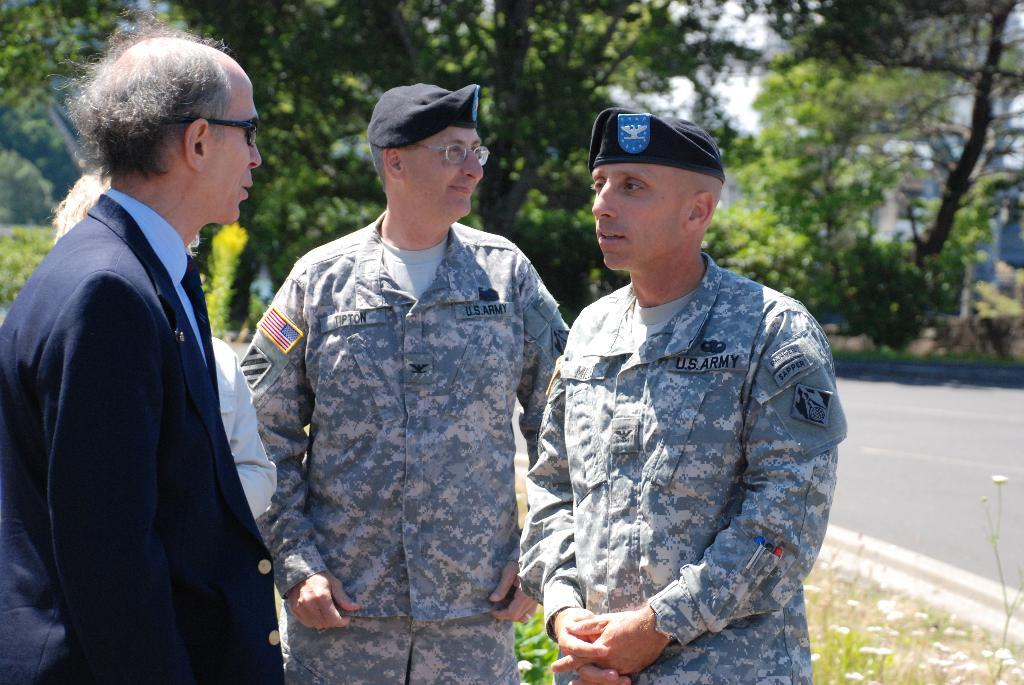Who is the main subject in the image? There is an old man in the image. What is the old man doing in the image? The old man is talking to an army official. Can you describe the other person in the image? There is another person in the background of the image, and they are looking somewhere. How many snails can be seen crawling on the army official's uniform in the image? There are no snails visible in the image. In which direction is the person in the background looking? The direction in which the person in the background is looking cannot be determined from the image. 